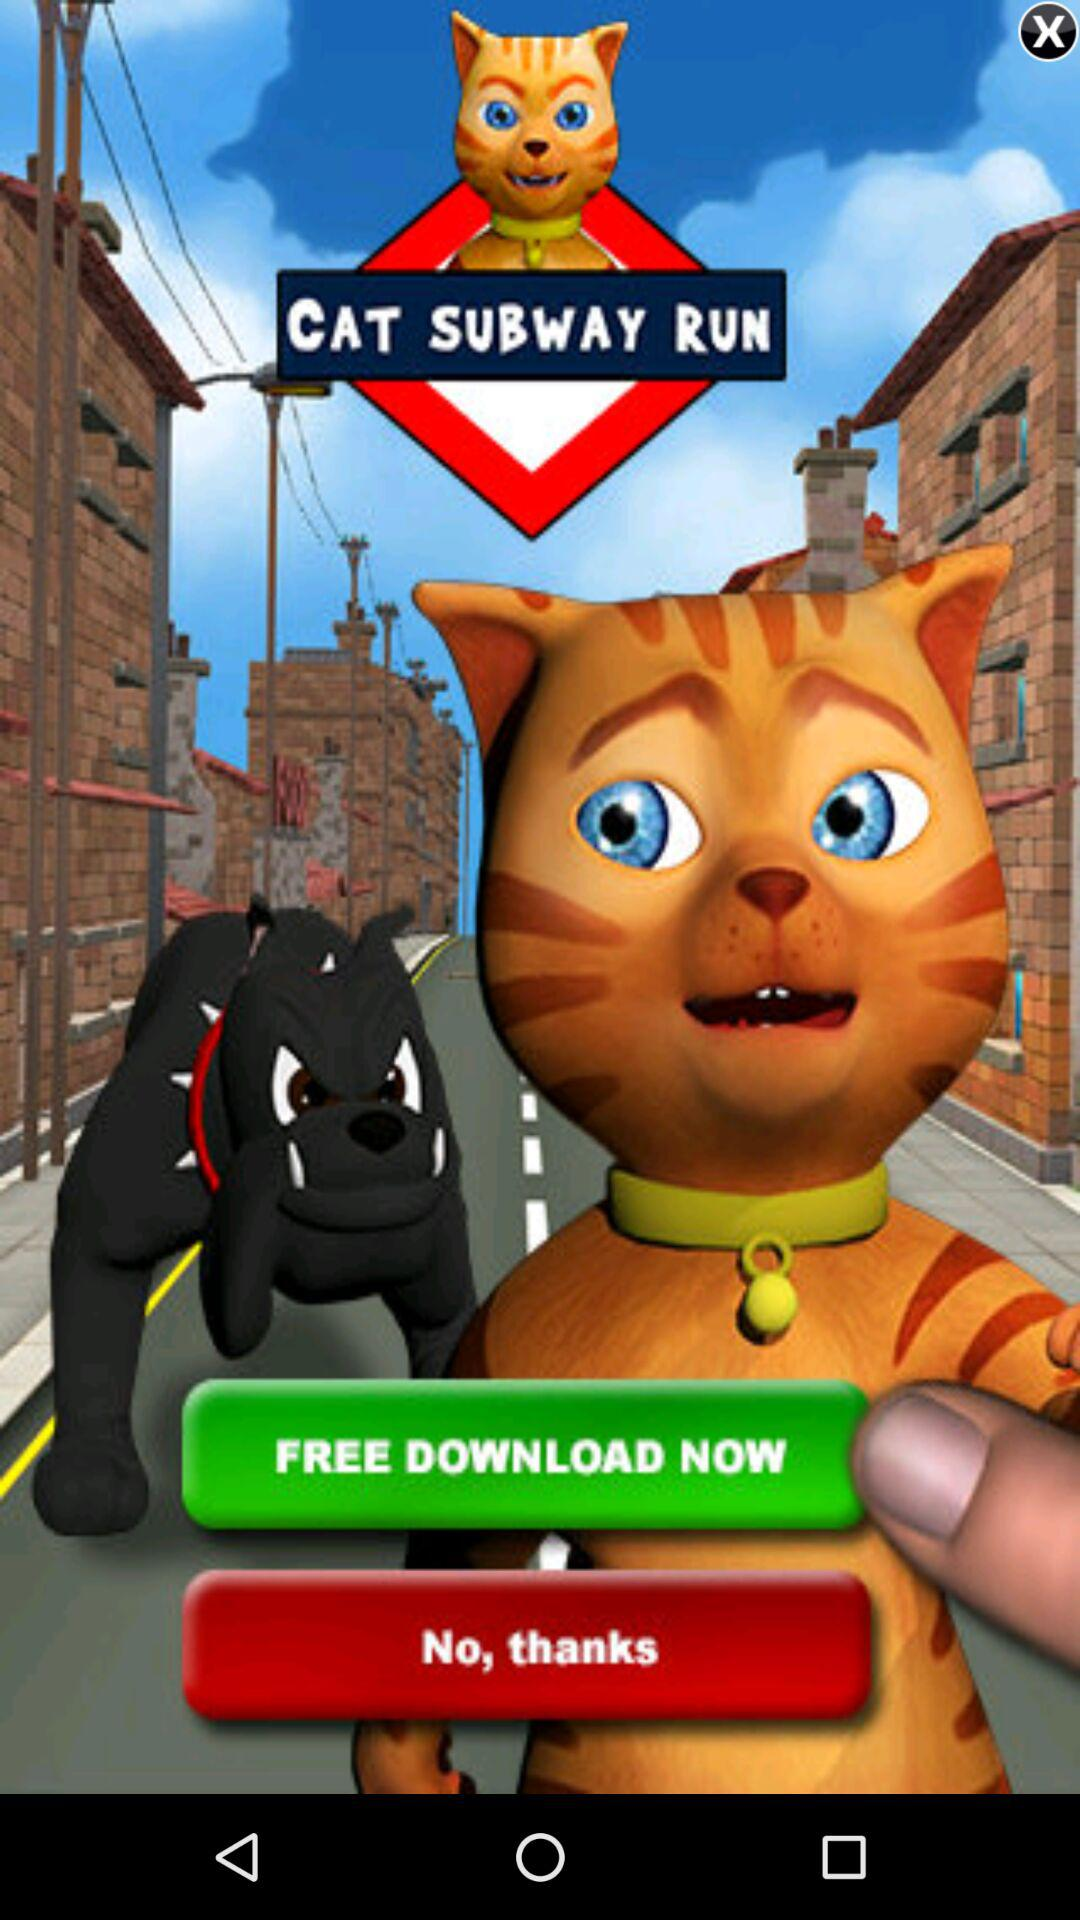What is the name of the application? The name of the application is "CAT SUBWAY RUN". 